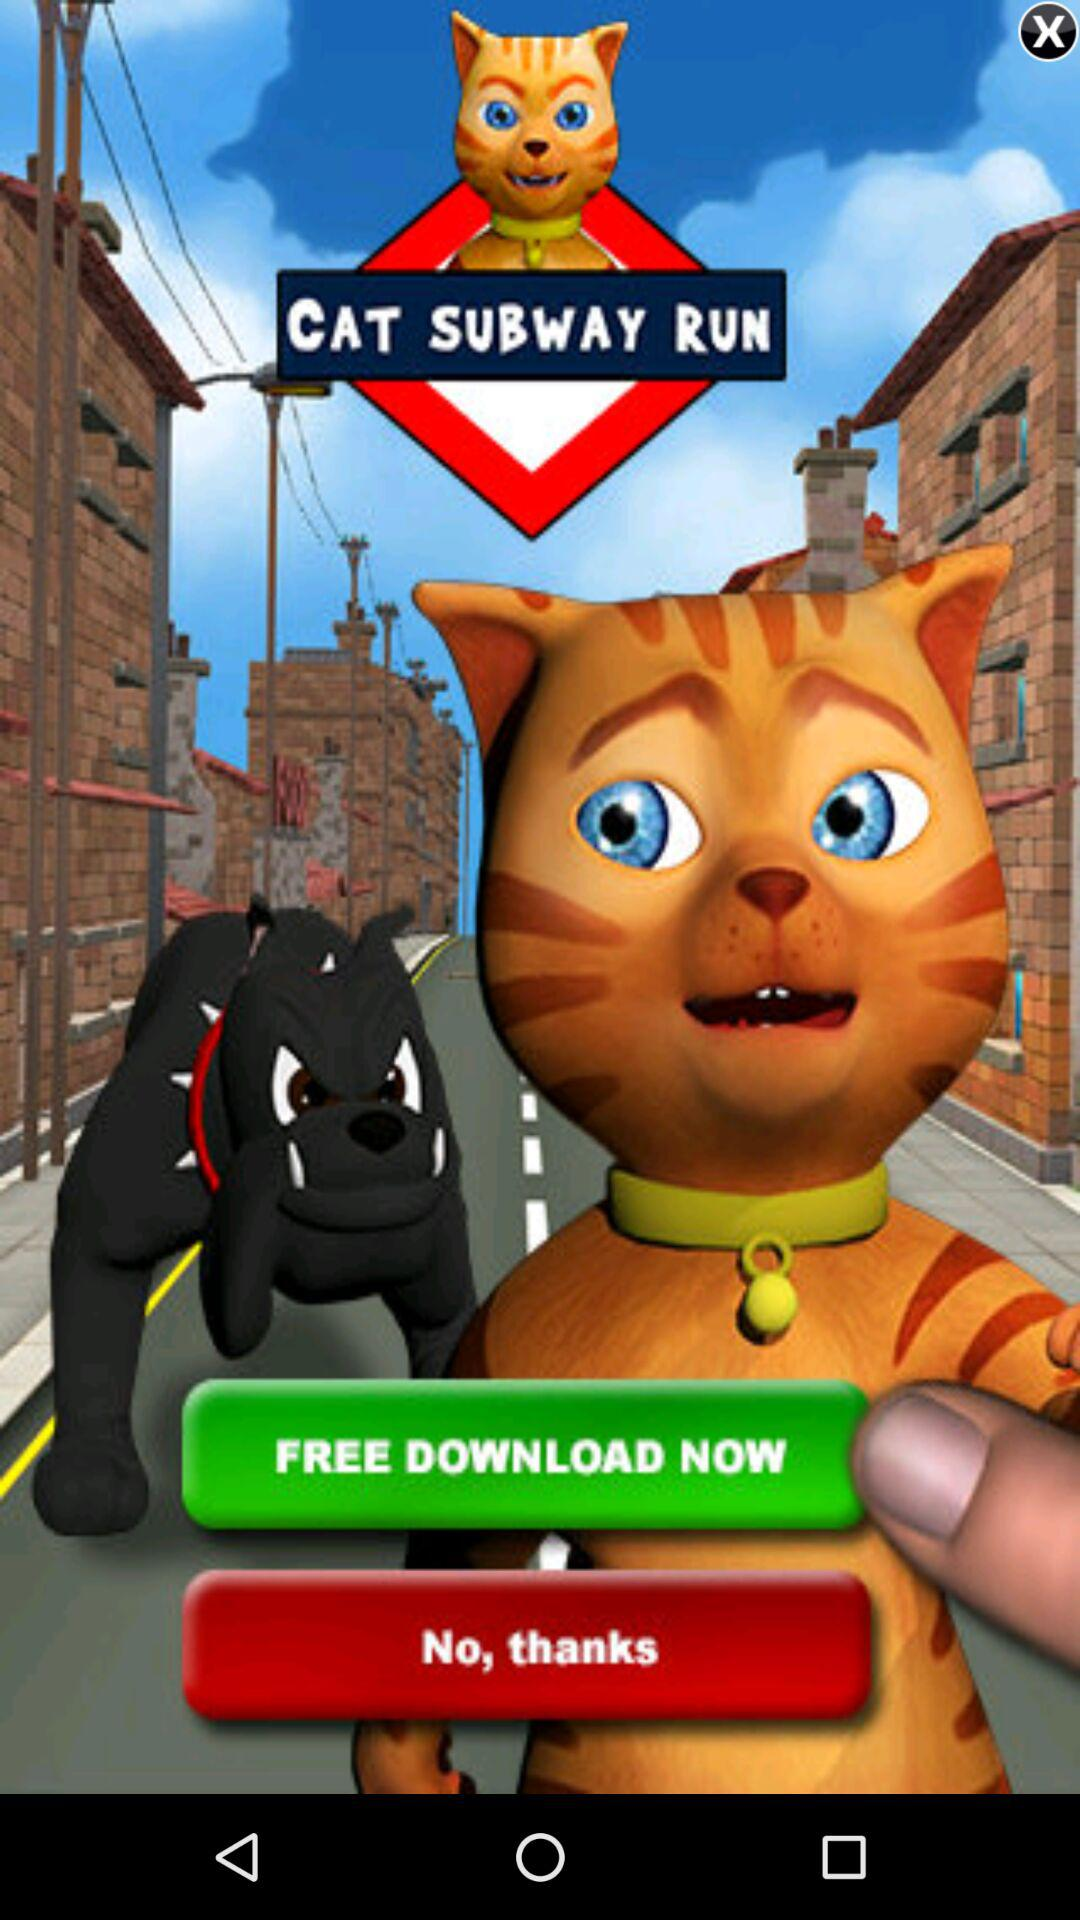What is the name of the application? The name of the application is "CAT SUBWAY RUN". 